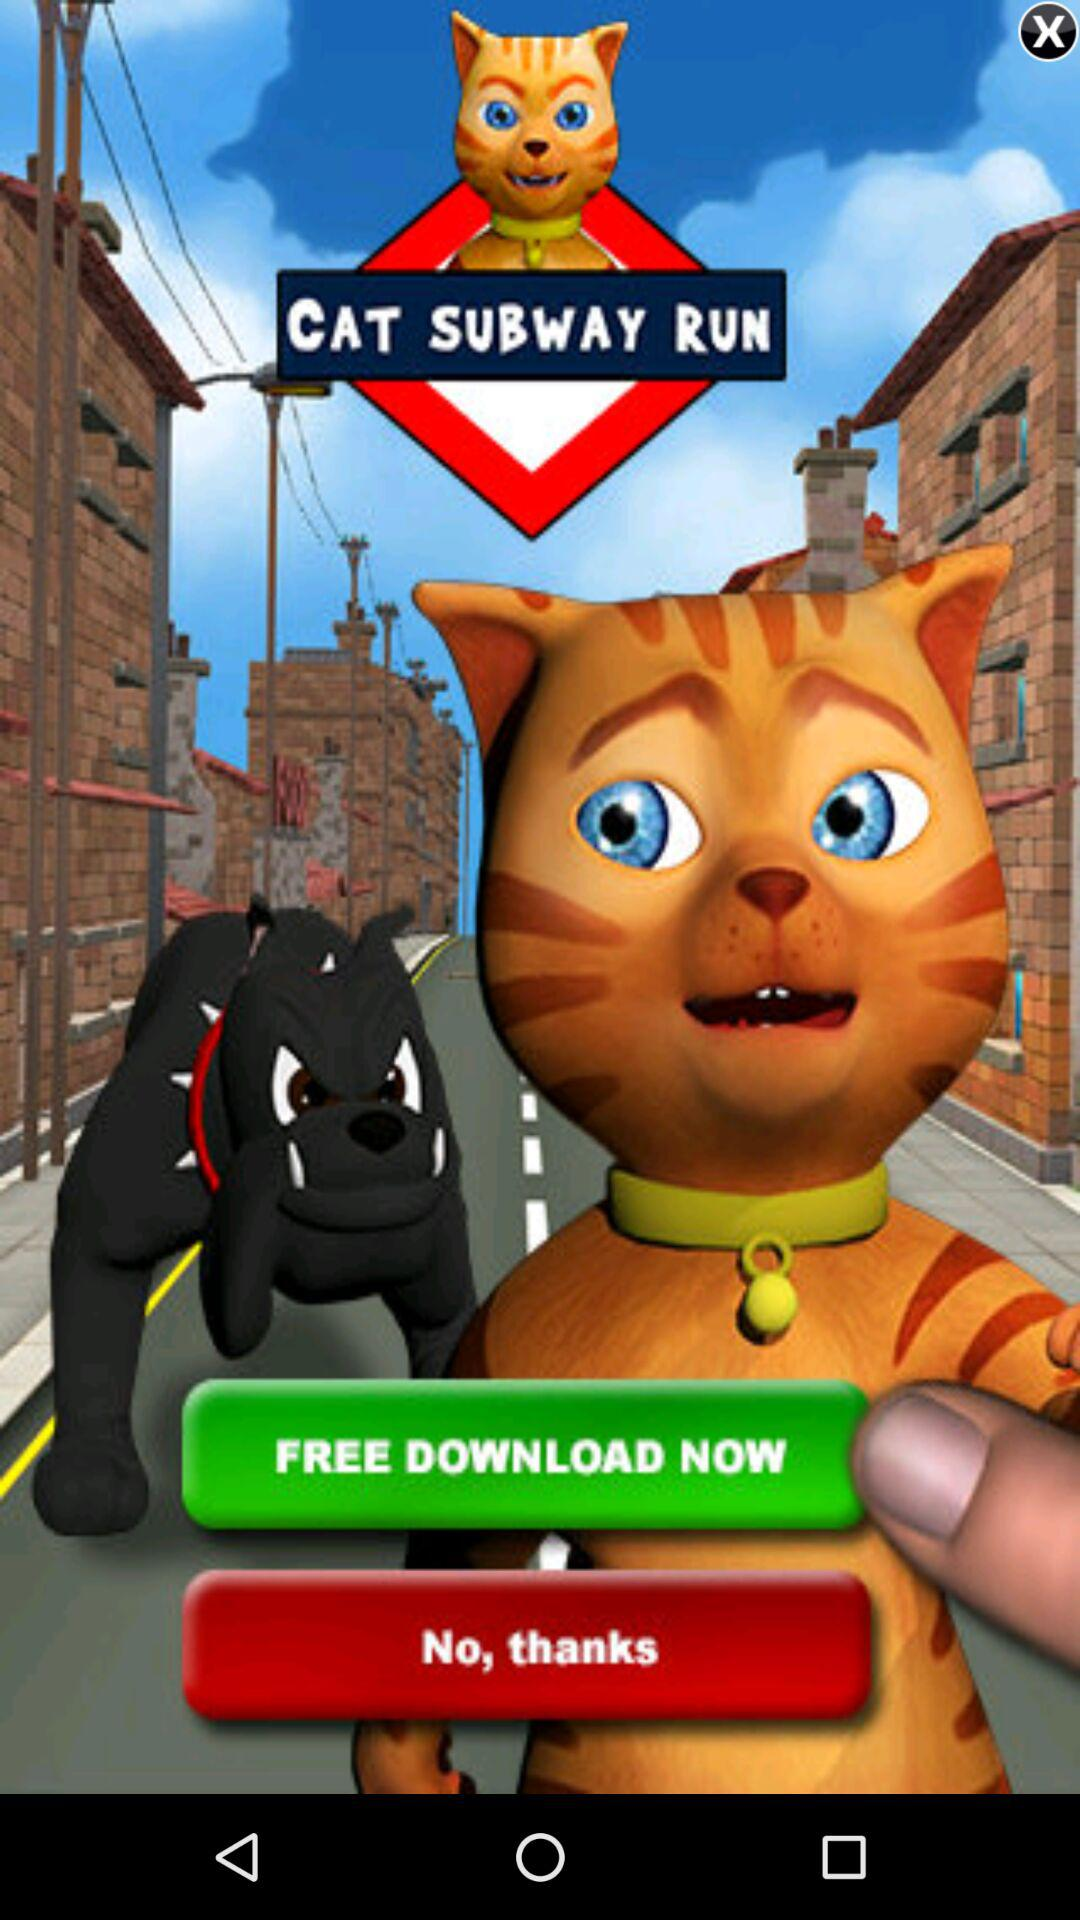What is the name of the application? The name of the application is "CAT SUBWAY RUN". 